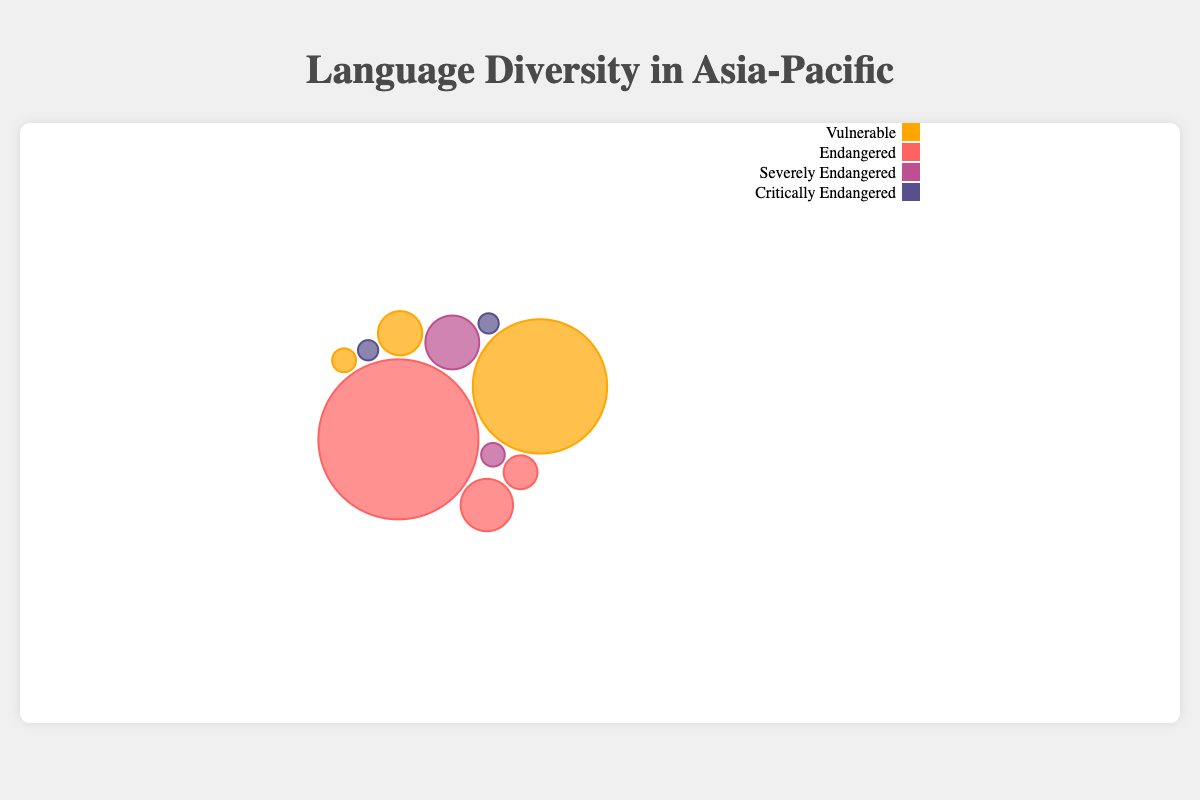What is the title of the figure? The title can be found at the top of the figure. It summarizes the main topic of the visualized data.
Answer: Language Diversity in Asia-Pacific Which language has the highest number of speakers? Look for the largest bubble in the figure, which represents the language with the highest number of speakers.
Answer: Hmong Daw How many languages are categorized as "Critically Endangered"? Refer to the legend to find the color representing "Critically Endangered" and then count the corresponding bubbles.
Answer: Two What is the total number of speakers for all the "Vulnerable" status languages? Identify the bubbles with "Vulnerable" status using the legend for their color, then sum their number of speakers: Tok Pisin (4,000,000) + Kui (180,000) + Yolngu Matha (4,600) = 4,184,600.
Answer: 4,184,600 Which two countries have critically endangered languages and what are those languages? Locate the bubbles for "Critically Endangered" status and note their countries: China (Manchu) and Japan (Ainu).
Answer: China (Manchu) and Japan (Ainu) Compare the number of speakers of "Rejang" and "Konyak". Which one has more? Look at the sizes of the bubbles for "Rejang" and "Konyak" and compare them; Rejang has 350,000 speakers, Konyak has 320,000 speakers.
Answer: Rejang has more Out of the countries listed, which one has the language with the highest number of speakers in the "Endangered" status? Check the legend for the color representing "Endangered" and find the largest bubble of that color, which is Hmong Daw in Vietnam with 6,000,000 speakers.
Answer: Vietnam What percentage of the total speakers is represented by "Chamorro"? First, sum the number of speakers from all languages: 4,000,000 + 6,000,000 + 350,000 + 58,000 + 20 + 15 + 320,000 + 180,000 + 4,000 + 4,600 = 10,916,635. Then calculate the percentage for Chamorro (58,000/10,916,635) × 100 ≈ 0.53%.
Answer: 0.53% Which language from Taiwan is included, and what is its status? Identify the bubble representing Taiwan and check its language and status: Saisiyat is the language, and it is "Severely Endangered".
Answer: Saisiyat (Severely Endangered) What is the average number of speakers for the "Endangered" languages? Identify the bubbles with "Endangered" status and sum their number of speakers: Hmong Daw (6,000,000) + Chamorro (58,000) + Konyak (320,000). Calculate the average by dividing the total by the number of languages: (6,000,000 + 58,000 + 320,000)/3 = 2,126,000.
Answer: 2,126,000 